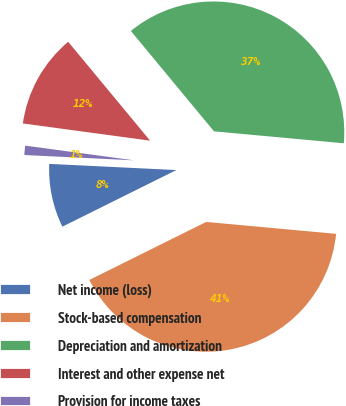Convert chart. <chart><loc_0><loc_0><loc_500><loc_500><pie_chart><fcel>Net income (loss)<fcel>Stock-based compensation<fcel>Depreciation and amortization<fcel>Interest and other expense net<fcel>Provision for income taxes<nl><fcel>8.11%<fcel>41.21%<fcel>37.47%<fcel>11.85%<fcel>1.37%<nl></chart> 